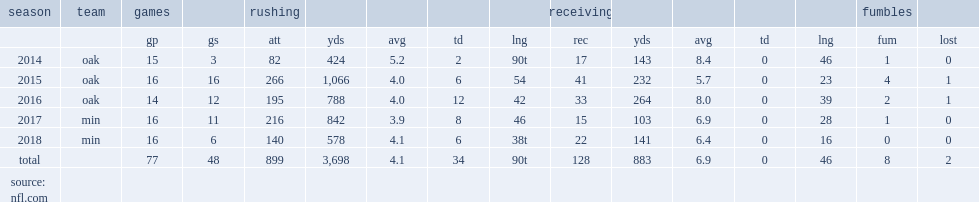Could you parse the entire table? {'header': ['season', 'team', 'games', '', 'rushing', '', '', '', '', 'receiving', '', '', '', '', 'fumbles', ''], 'rows': [['', '', 'gp', 'gs', 'att', 'yds', 'avg', 'td', 'lng', 'rec', 'yds', 'avg', 'td', 'lng', 'fum', 'lost'], ['2014', 'oak', '15', '3', '82', '424', '5.2', '2', '90t', '17', '143', '8.4', '0', '46', '1', '0'], ['2015', 'oak', '16', '16', '266', '1,066', '4.0', '6', '54', '41', '232', '5.7', '0', '23', '4', '1'], ['2016', 'oak', '14', '12', '195', '788', '4.0', '12', '42', '33', '264', '8.0', '0', '39', '2', '1'], ['2017', 'min', '16', '11', '216', '842', '3.9', '8', '46', '15', '103', '6.9', '0', '28', '1', '0'], ['2018', 'min', '16', '6', '140', '578', '4.1', '6', '38t', '22', '141', '6.4', '0', '16', '0', '0'], ['total', '', '77', '48', '899', '3,698', '4.1', '34', '90t', '128', '883', '6.9', '0', '46', '8', '2'], ['source: nfl.com', '', '', '', '', '', '', '', '', '', '', '', '', '', '', '']]} How many rushing yards did murray get in 2018? 578.0. 